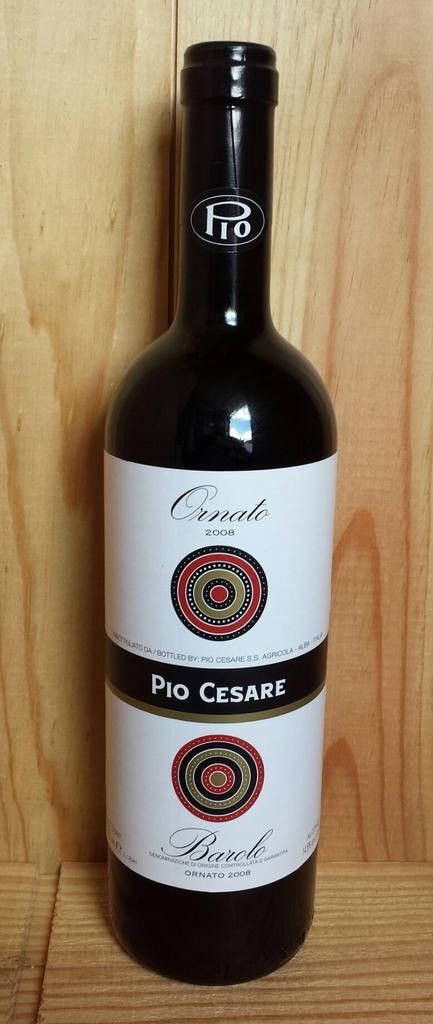What is the brand of this wine?
Provide a succinct answer. Pio cesare. 